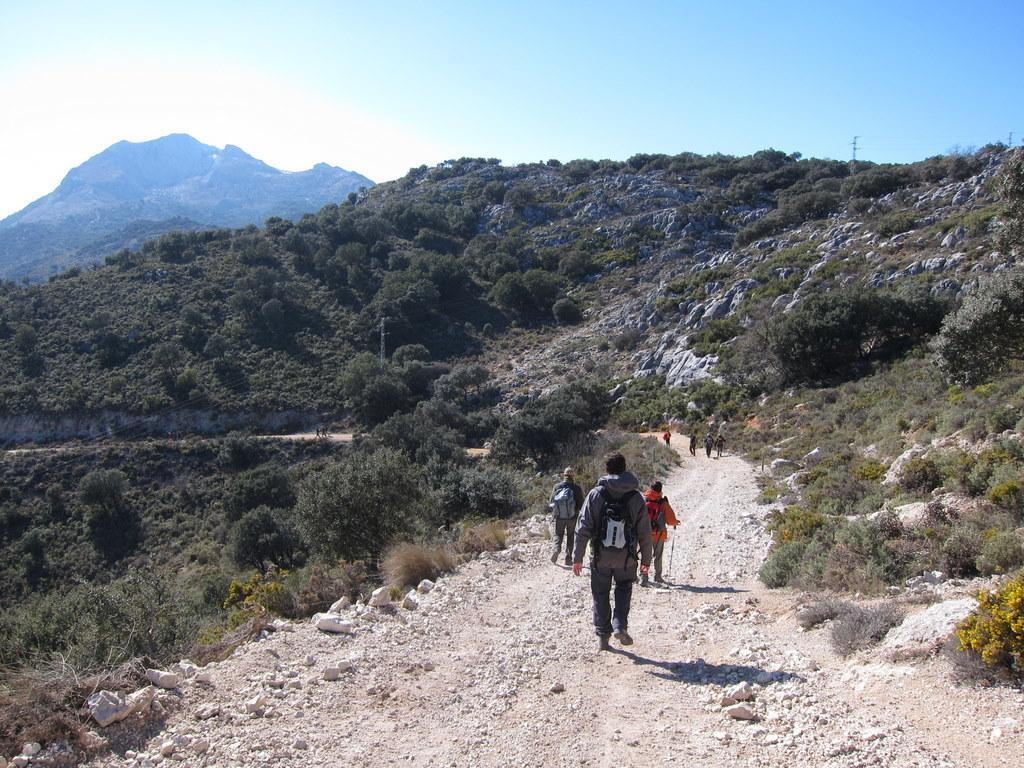How many people are in the image? There are people in the image. What activity are the people engaged in? The people are trekking. Where is the trekking taking place? The trekking is taking place between mountains. Can you tell me how many times the people exchanged their trekking gear in the image? There is no information about any gear exchange in the image. What type of taste can be experienced from the mountains in the image? The image does not depict any taste or sensory experience related to the mountains. 